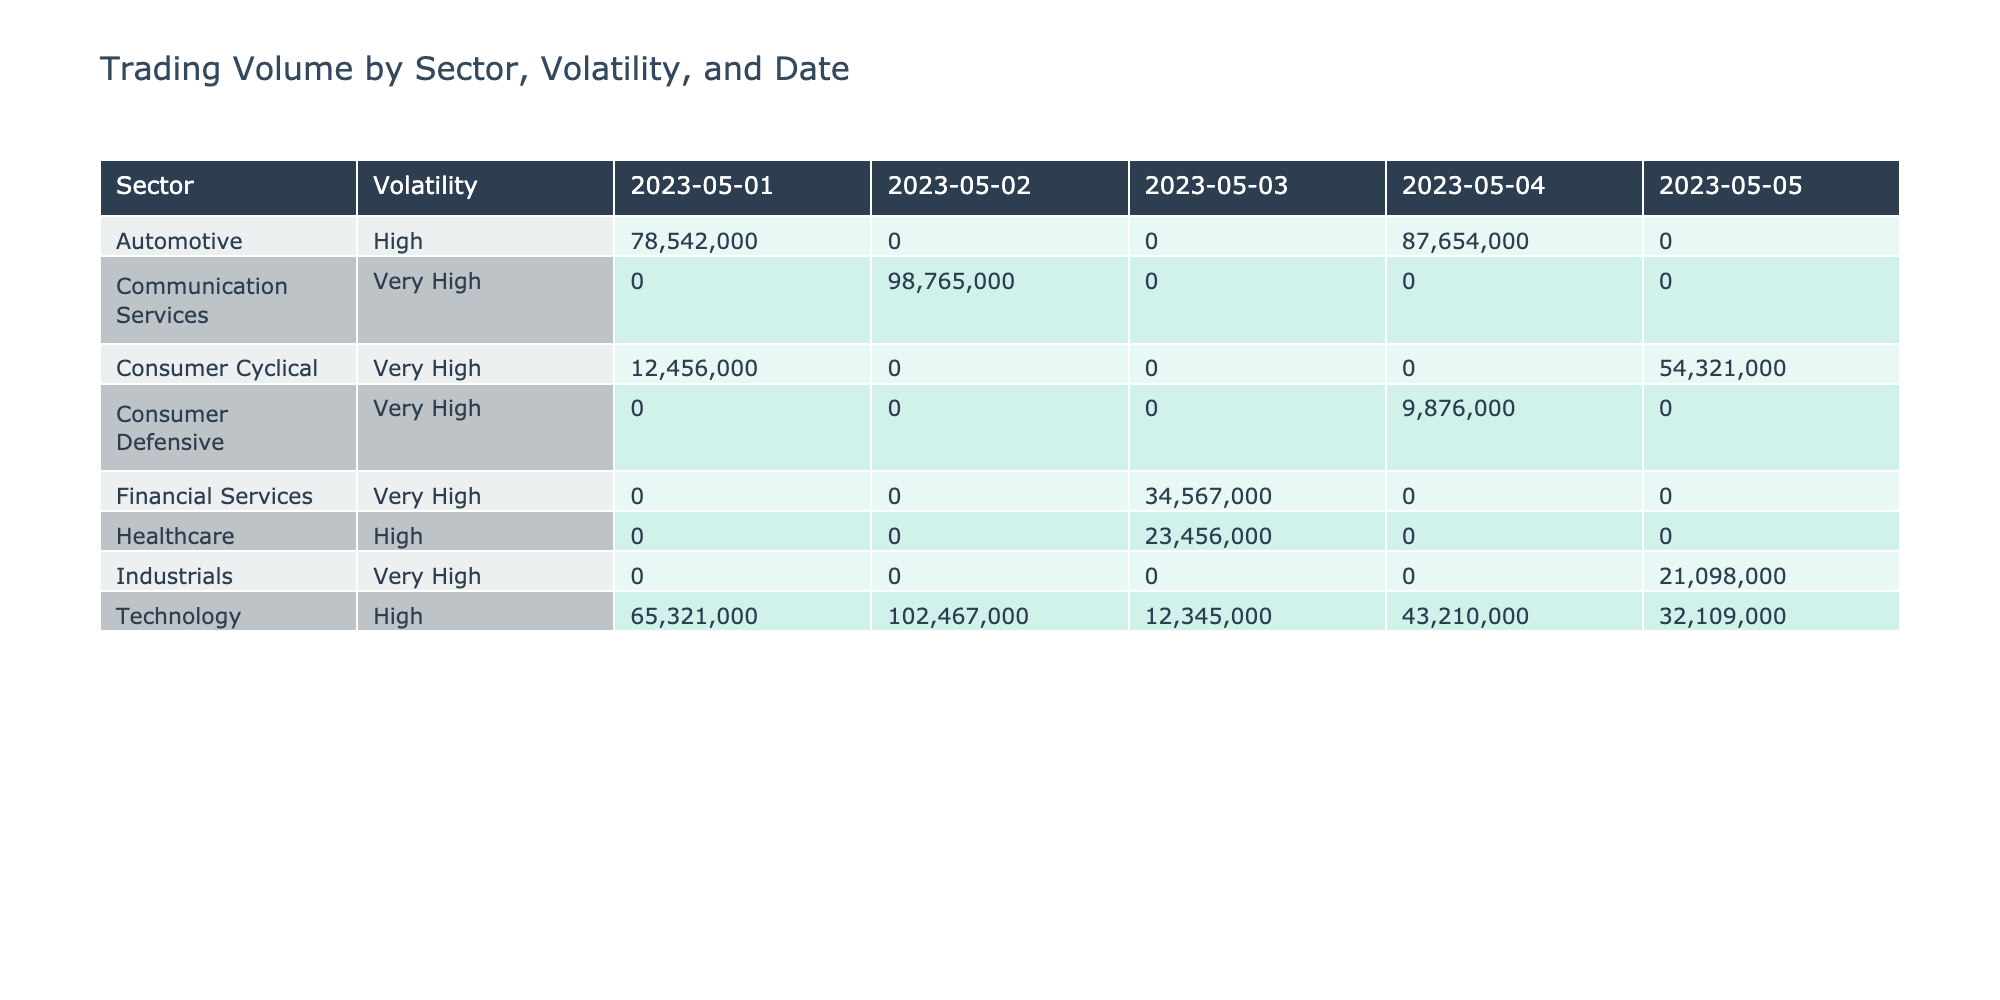What is the total trading volume for the "Technology" sector on 2023-05-01? From the table, the trading volume for the "Technology" sector on that date is 65,321,000 (AMD) + 45,678,000 (Nvidia) = 110,999,000.
Answer: 110,999,000 Which sector has the highest trading volume on 2023-05-02? The table shows that "Communication Services" with AMC Entertainment has a trading volume of 98,765,000, which is greater than other sectors on that date.
Answer: Communication Services Is there any "High" volatility stock in the "Healthcare" sector? Referring to the table, "Healthcare" contains only Moderna and it has "High" volatility.
Answer: Yes What is the average trading volume of "Very High" volatility stocks? First, we identify "Very High" volatility stocks: GameStop (12,456,000), AMC Entertainment (98,765,000), Beyond Meat (9,876,000), Peloton (54,321,000), and Virgin Galactic (21,098,000). Summing these gives 196,416,000. Dividing by the number of stocks, which is 5, we get the average 196,416,000 / 5 = 39,283,200.
Answer: 39,283,200 Which stock has the lowest trading volume on 2023-05-04? The table lists the trading volumes for that date: NIO (87,654,000), Roku (43,210,000), and Beyond Meat (9,876,000). Beyond Meat has the lowest trading volume at 9,876,000.
Answer: Beyond Meat 